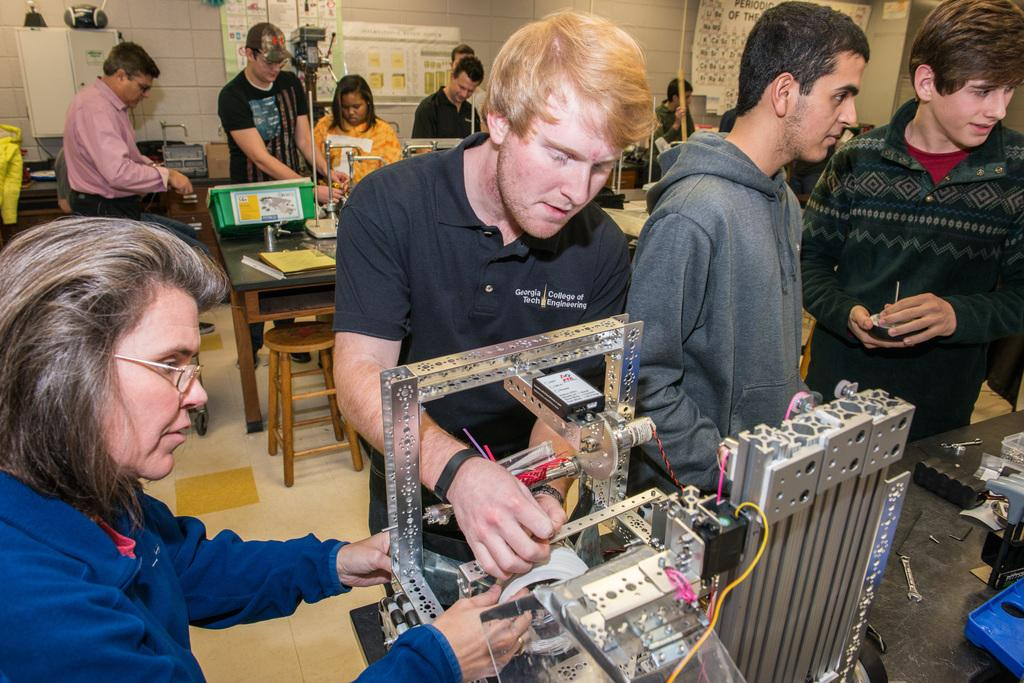What is happening in the room in the image? There are people standing in the room. What can be found in the room besides the people? There is a table in the room. What is on the table? There are machines on the table. What decorations are on the walls? There are posters on the walls. Can you see a mountain in the image? No, there is no mountain present in the image. What is being copied in the image? There is no copying activity depicted in the image. 